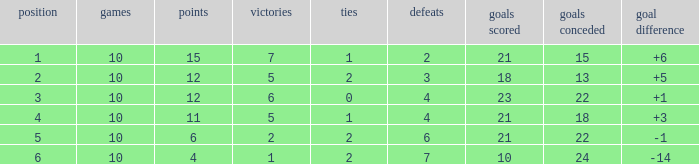Can you tell me the total number of Wins that has the Draws larger than 0, and the Points of 11? 1.0. 